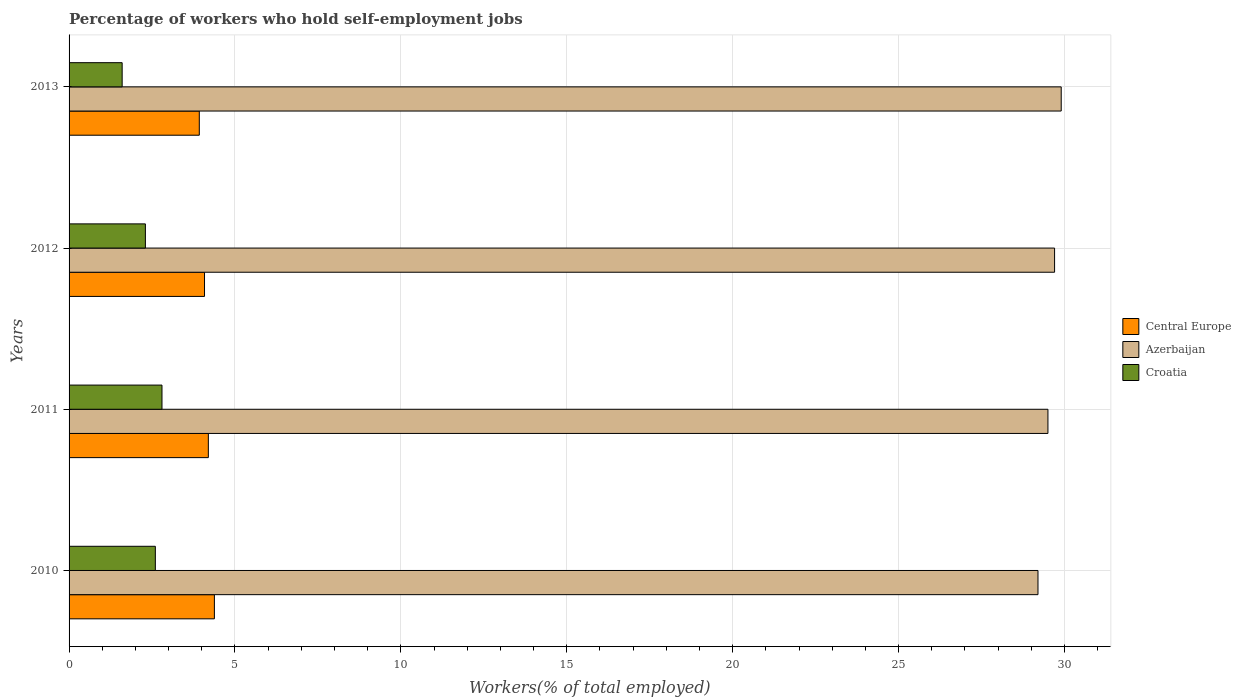How many groups of bars are there?
Offer a terse response. 4. Are the number of bars on each tick of the Y-axis equal?
Offer a terse response. Yes. In how many cases, is the number of bars for a given year not equal to the number of legend labels?
Offer a terse response. 0. What is the percentage of self-employed workers in Azerbaijan in 2010?
Offer a very short reply. 29.2. Across all years, what is the maximum percentage of self-employed workers in Azerbaijan?
Provide a succinct answer. 29.9. Across all years, what is the minimum percentage of self-employed workers in Central Europe?
Offer a terse response. 3.92. What is the total percentage of self-employed workers in Croatia in the graph?
Your answer should be very brief. 9.3. What is the difference between the percentage of self-employed workers in Central Europe in 2013 and the percentage of self-employed workers in Azerbaijan in 2012?
Give a very brief answer. -25.78. What is the average percentage of self-employed workers in Central Europe per year?
Offer a very short reply. 4.15. In the year 2010, what is the difference between the percentage of self-employed workers in Azerbaijan and percentage of self-employed workers in Croatia?
Offer a terse response. 26.6. In how many years, is the percentage of self-employed workers in Croatia greater than 15 %?
Ensure brevity in your answer.  0. What is the ratio of the percentage of self-employed workers in Azerbaijan in 2011 to that in 2013?
Ensure brevity in your answer.  0.99. Is the percentage of self-employed workers in Croatia in 2012 less than that in 2013?
Keep it short and to the point. No. What is the difference between the highest and the second highest percentage of self-employed workers in Azerbaijan?
Your answer should be very brief. 0.2. What is the difference between the highest and the lowest percentage of self-employed workers in Croatia?
Ensure brevity in your answer.  1.2. In how many years, is the percentage of self-employed workers in Azerbaijan greater than the average percentage of self-employed workers in Azerbaijan taken over all years?
Offer a terse response. 2. What does the 2nd bar from the top in 2011 represents?
Ensure brevity in your answer.  Azerbaijan. What does the 1st bar from the bottom in 2011 represents?
Your answer should be very brief. Central Europe. Are all the bars in the graph horizontal?
Give a very brief answer. Yes. How many years are there in the graph?
Your response must be concise. 4. Are the values on the major ticks of X-axis written in scientific E-notation?
Offer a very short reply. No. Does the graph contain any zero values?
Your response must be concise. No. How many legend labels are there?
Ensure brevity in your answer.  3. How are the legend labels stacked?
Ensure brevity in your answer.  Vertical. What is the title of the graph?
Provide a short and direct response. Percentage of workers who hold self-employment jobs. Does "Latin America(developing only)" appear as one of the legend labels in the graph?
Make the answer very short. No. What is the label or title of the X-axis?
Your answer should be very brief. Workers(% of total employed). What is the Workers(% of total employed) in Central Europe in 2010?
Offer a terse response. 4.38. What is the Workers(% of total employed) in Azerbaijan in 2010?
Your answer should be compact. 29.2. What is the Workers(% of total employed) in Croatia in 2010?
Give a very brief answer. 2.6. What is the Workers(% of total employed) in Central Europe in 2011?
Provide a succinct answer. 4.2. What is the Workers(% of total employed) of Azerbaijan in 2011?
Your response must be concise. 29.5. What is the Workers(% of total employed) in Croatia in 2011?
Your answer should be compact. 2.8. What is the Workers(% of total employed) of Central Europe in 2012?
Give a very brief answer. 4.08. What is the Workers(% of total employed) in Azerbaijan in 2012?
Keep it short and to the point. 29.7. What is the Workers(% of total employed) of Croatia in 2012?
Keep it short and to the point. 2.3. What is the Workers(% of total employed) of Central Europe in 2013?
Give a very brief answer. 3.92. What is the Workers(% of total employed) in Azerbaijan in 2013?
Keep it short and to the point. 29.9. What is the Workers(% of total employed) in Croatia in 2013?
Provide a succinct answer. 1.6. Across all years, what is the maximum Workers(% of total employed) in Central Europe?
Make the answer very short. 4.38. Across all years, what is the maximum Workers(% of total employed) of Azerbaijan?
Your answer should be very brief. 29.9. Across all years, what is the maximum Workers(% of total employed) in Croatia?
Ensure brevity in your answer.  2.8. Across all years, what is the minimum Workers(% of total employed) of Central Europe?
Your answer should be compact. 3.92. Across all years, what is the minimum Workers(% of total employed) of Azerbaijan?
Your response must be concise. 29.2. Across all years, what is the minimum Workers(% of total employed) in Croatia?
Provide a succinct answer. 1.6. What is the total Workers(% of total employed) of Central Europe in the graph?
Make the answer very short. 16.58. What is the total Workers(% of total employed) of Azerbaijan in the graph?
Ensure brevity in your answer.  118.3. What is the difference between the Workers(% of total employed) of Central Europe in 2010 and that in 2011?
Make the answer very short. 0.18. What is the difference between the Workers(% of total employed) in Azerbaijan in 2010 and that in 2011?
Provide a succinct answer. -0.3. What is the difference between the Workers(% of total employed) of Central Europe in 2010 and that in 2012?
Your answer should be very brief. 0.3. What is the difference between the Workers(% of total employed) in Azerbaijan in 2010 and that in 2012?
Provide a short and direct response. -0.5. What is the difference between the Workers(% of total employed) in Central Europe in 2010 and that in 2013?
Give a very brief answer. 0.46. What is the difference between the Workers(% of total employed) in Croatia in 2010 and that in 2013?
Give a very brief answer. 1. What is the difference between the Workers(% of total employed) of Central Europe in 2011 and that in 2012?
Give a very brief answer. 0.12. What is the difference between the Workers(% of total employed) of Azerbaijan in 2011 and that in 2012?
Provide a short and direct response. -0.2. What is the difference between the Workers(% of total employed) in Croatia in 2011 and that in 2012?
Offer a very short reply. 0.5. What is the difference between the Workers(% of total employed) in Central Europe in 2011 and that in 2013?
Offer a very short reply. 0.27. What is the difference between the Workers(% of total employed) in Azerbaijan in 2011 and that in 2013?
Your response must be concise. -0.4. What is the difference between the Workers(% of total employed) in Central Europe in 2012 and that in 2013?
Your answer should be very brief. 0.16. What is the difference between the Workers(% of total employed) of Azerbaijan in 2012 and that in 2013?
Your response must be concise. -0.2. What is the difference between the Workers(% of total employed) in Central Europe in 2010 and the Workers(% of total employed) in Azerbaijan in 2011?
Keep it short and to the point. -25.12. What is the difference between the Workers(% of total employed) of Central Europe in 2010 and the Workers(% of total employed) of Croatia in 2011?
Give a very brief answer. 1.58. What is the difference between the Workers(% of total employed) of Azerbaijan in 2010 and the Workers(% of total employed) of Croatia in 2011?
Your answer should be compact. 26.4. What is the difference between the Workers(% of total employed) in Central Europe in 2010 and the Workers(% of total employed) in Azerbaijan in 2012?
Your response must be concise. -25.32. What is the difference between the Workers(% of total employed) of Central Europe in 2010 and the Workers(% of total employed) of Croatia in 2012?
Make the answer very short. 2.08. What is the difference between the Workers(% of total employed) of Azerbaijan in 2010 and the Workers(% of total employed) of Croatia in 2012?
Your answer should be very brief. 26.9. What is the difference between the Workers(% of total employed) of Central Europe in 2010 and the Workers(% of total employed) of Azerbaijan in 2013?
Offer a very short reply. -25.52. What is the difference between the Workers(% of total employed) in Central Europe in 2010 and the Workers(% of total employed) in Croatia in 2013?
Make the answer very short. 2.78. What is the difference between the Workers(% of total employed) of Azerbaijan in 2010 and the Workers(% of total employed) of Croatia in 2013?
Your response must be concise. 27.6. What is the difference between the Workers(% of total employed) of Central Europe in 2011 and the Workers(% of total employed) of Azerbaijan in 2012?
Your response must be concise. -25.5. What is the difference between the Workers(% of total employed) of Central Europe in 2011 and the Workers(% of total employed) of Croatia in 2012?
Your response must be concise. 1.9. What is the difference between the Workers(% of total employed) in Azerbaijan in 2011 and the Workers(% of total employed) in Croatia in 2012?
Offer a terse response. 27.2. What is the difference between the Workers(% of total employed) of Central Europe in 2011 and the Workers(% of total employed) of Azerbaijan in 2013?
Offer a very short reply. -25.7. What is the difference between the Workers(% of total employed) in Central Europe in 2011 and the Workers(% of total employed) in Croatia in 2013?
Provide a short and direct response. 2.6. What is the difference between the Workers(% of total employed) of Azerbaijan in 2011 and the Workers(% of total employed) of Croatia in 2013?
Offer a terse response. 27.9. What is the difference between the Workers(% of total employed) of Central Europe in 2012 and the Workers(% of total employed) of Azerbaijan in 2013?
Ensure brevity in your answer.  -25.82. What is the difference between the Workers(% of total employed) in Central Europe in 2012 and the Workers(% of total employed) in Croatia in 2013?
Make the answer very short. 2.48. What is the difference between the Workers(% of total employed) of Azerbaijan in 2012 and the Workers(% of total employed) of Croatia in 2013?
Ensure brevity in your answer.  28.1. What is the average Workers(% of total employed) in Central Europe per year?
Provide a short and direct response. 4.15. What is the average Workers(% of total employed) in Azerbaijan per year?
Provide a succinct answer. 29.57. What is the average Workers(% of total employed) in Croatia per year?
Make the answer very short. 2.33. In the year 2010, what is the difference between the Workers(% of total employed) in Central Europe and Workers(% of total employed) in Azerbaijan?
Keep it short and to the point. -24.82. In the year 2010, what is the difference between the Workers(% of total employed) in Central Europe and Workers(% of total employed) in Croatia?
Provide a succinct answer. 1.78. In the year 2010, what is the difference between the Workers(% of total employed) of Azerbaijan and Workers(% of total employed) of Croatia?
Your answer should be compact. 26.6. In the year 2011, what is the difference between the Workers(% of total employed) of Central Europe and Workers(% of total employed) of Azerbaijan?
Offer a terse response. -25.3. In the year 2011, what is the difference between the Workers(% of total employed) in Central Europe and Workers(% of total employed) in Croatia?
Keep it short and to the point. 1.4. In the year 2011, what is the difference between the Workers(% of total employed) of Azerbaijan and Workers(% of total employed) of Croatia?
Offer a terse response. 26.7. In the year 2012, what is the difference between the Workers(% of total employed) of Central Europe and Workers(% of total employed) of Azerbaijan?
Your answer should be very brief. -25.62. In the year 2012, what is the difference between the Workers(% of total employed) in Central Europe and Workers(% of total employed) in Croatia?
Ensure brevity in your answer.  1.78. In the year 2012, what is the difference between the Workers(% of total employed) in Azerbaijan and Workers(% of total employed) in Croatia?
Provide a succinct answer. 27.4. In the year 2013, what is the difference between the Workers(% of total employed) of Central Europe and Workers(% of total employed) of Azerbaijan?
Provide a succinct answer. -25.98. In the year 2013, what is the difference between the Workers(% of total employed) in Central Europe and Workers(% of total employed) in Croatia?
Provide a succinct answer. 2.32. In the year 2013, what is the difference between the Workers(% of total employed) of Azerbaijan and Workers(% of total employed) of Croatia?
Your answer should be very brief. 28.3. What is the ratio of the Workers(% of total employed) in Central Europe in 2010 to that in 2011?
Offer a terse response. 1.04. What is the ratio of the Workers(% of total employed) in Azerbaijan in 2010 to that in 2011?
Ensure brevity in your answer.  0.99. What is the ratio of the Workers(% of total employed) of Croatia in 2010 to that in 2011?
Make the answer very short. 0.93. What is the ratio of the Workers(% of total employed) in Central Europe in 2010 to that in 2012?
Give a very brief answer. 1.07. What is the ratio of the Workers(% of total employed) in Azerbaijan in 2010 to that in 2012?
Keep it short and to the point. 0.98. What is the ratio of the Workers(% of total employed) of Croatia in 2010 to that in 2012?
Your answer should be very brief. 1.13. What is the ratio of the Workers(% of total employed) in Central Europe in 2010 to that in 2013?
Keep it short and to the point. 1.12. What is the ratio of the Workers(% of total employed) in Azerbaijan in 2010 to that in 2013?
Offer a very short reply. 0.98. What is the ratio of the Workers(% of total employed) in Croatia in 2010 to that in 2013?
Provide a succinct answer. 1.62. What is the ratio of the Workers(% of total employed) in Central Europe in 2011 to that in 2012?
Ensure brevity in your answer.  1.03. What is the ratio of the Workers(% of total employed) of Croatia in 2011 to that in 2012?
Your response must be concise. 1.22. What is the ratio of the Workers(% of total employed) in Central Europe in 2011 to that in 2013?
Give a very brief answer. 1.07. What is the ratio of the Workers(% of total employed) of Azerbaijan in 2011 to that in 2013?
Provide a short and direct response. 0.99. What is the ratio of the Workers(% of total employed) in Croatia in 2011 to that in 2013?
Keep it short and to the point. 1.75. What is the ratio of the Workers(% of total employed) of Central Europe in 2012 to that in 2013?
Your answer should be very brief. 1.04. What is the ratio of the Workers(% of total employed) of Azerbaijan in 2012 to that in 2013?
Keep it short and to the point. 0.99. What is the ratio of the Workers(% of total employed) of Croatia in 2012 to that in 2013?
Your response must be concise. 1.44. What is the difference between the highest and the second highest Workers(% of total employed) of Central Europe?
Your response must be concise. 0.18. What is the difference between the highest and the second highest Workers(% of total employed) of Azerbaijan?
Keep it short and to the point. 0.2. What is the difference between the highest and the second highest Workers(% of total employed) in Croatia?
Your response must be concise. 0.2. What is the difference between the highest and the lowest Workers(% of total employed) of Central Europe?
Give a very brief answer. 0.46. What is the difference between the highest and the lowest Workers(% of total employed) in Azerbaijan?
Offer a terse response. 0.7. 